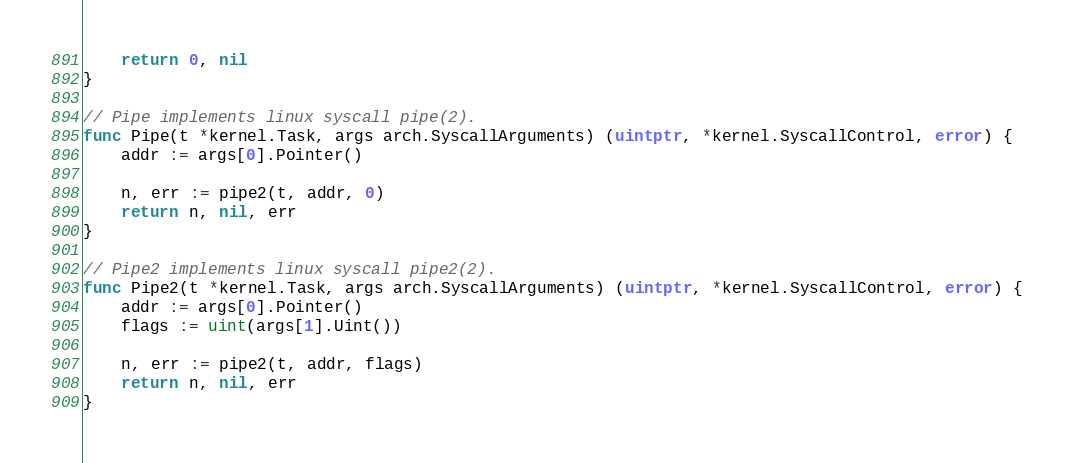<code> <loc_0><loc_0><loc_500><loc_500><_Go_>	return 0, nil
}

// Pipe implements linux syscall pipe(2).
func Pipe(t *kernel.Task, args arch.SyscallArguments) (uintptr, *kernel.SyscallControl, error) {
	addr := args[0].Pointer()

	n, err := pipe2(t, addr, 0)
	return n, nil, err
}

// Pipe2 implements linux syscall pipe2(2).
func Pipe2(t *kernel.Task, args arch.SyscallArguments) (uintptr, *kernel.SyscallControl, error) {
	addr := args[0].Pointer()
	flags := uint(args[1].Uint())

	n, err := pipe2(t, addr, flags)
	return n, nil, err
}
</code> 